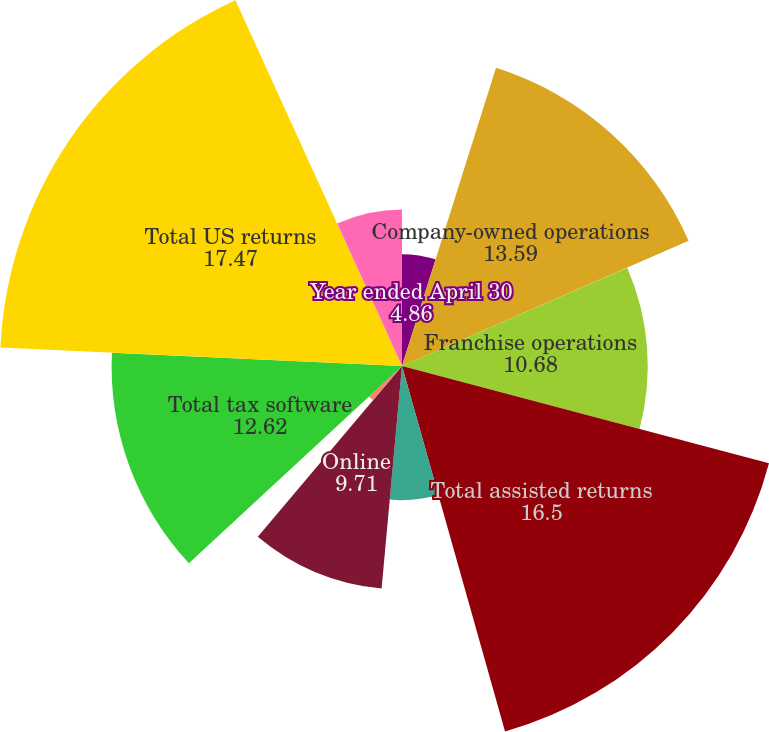<chart> <loc_0><loc_0><loc_500><loc_500><pie_chart><fcel>Year ended April 30<fcel>Company-owned operations<fcel>Franchise operations<fcel>Total assisted returns<fcel>Desktop<fcel>Online<fcel>Free File Alliance<fcel>Total tax software<fcel>Total US returns<fcel>Canada (1)<nl><fcel>4.86%<fcel>13.59%<fcel>10.68%<fcel>16.5%<fcel>5.83%<fcel>9.71%<fcel>1.95%<fcel>12.62%<fcel>17.47%<fcel>6.8%<nl></chart> 